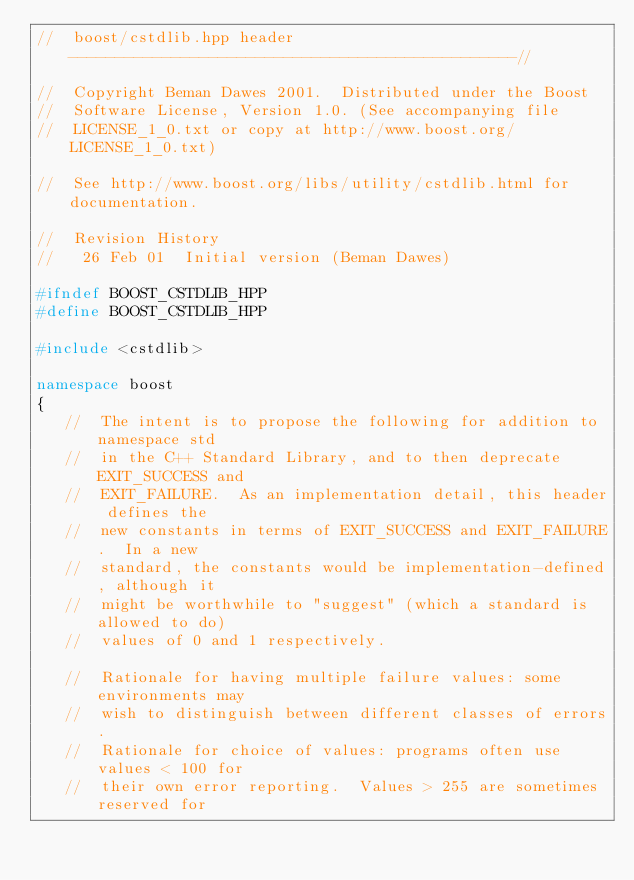<code> <loc_0><loc_0><loc_500><loc_500><_C++_>//  boost/cstdlib.hpp header  ------------------------------------------------//

//  Copyright Beman Dawes 2001.  Distributed under the Boost
//  Software License, Version 1.0. (See accompanying file
//  LICENSE_1_0.txt or copy at http://www.boost.org/LICENSE_1_0.txt)

//  See http://www.boost.org/libs/utility/cstdlib.html for documentation.

//  Revision History
//   26 Feb 01  Initial version (Beman Dawes)

#ifndef BOOST_CSTDLIB_HPP
#define BOOST_CSTDLIB_HPP

#include <cstdlib>

namespace boost
{
   //  The intent is to propose the following for addition to namespace std
   //  in the C++ Standard Library, and to then deprecate EXIT_SUCCESS and
   //  EXIT_FAILURE.  As an implementation detail, this header defines the
   //  new constants in terms of EXIT_SUCCESS and EXIT_FAILURE.  In a new
   //  standard, the constants would be implementation-defined, although it
   //  might be worthwhile to "suggest" (which a standard is allowed to do)
   //  values of 0 and 1 respectively.

   //  Rationale for having multiple failure values: some environments may
   //  wish to distinguish between different classes of errors.
   //  Rationale for choice of values: programs often use values < 100 for
   //  their own error reporting.  Values > 255 are sometimes reserved for</code> 